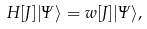<formula> <loc_0><loc_0><loc_500><loc_500>H [ J ] | \Psi \rangle = w [ J ] | \Psi \rangle ,</formula> 